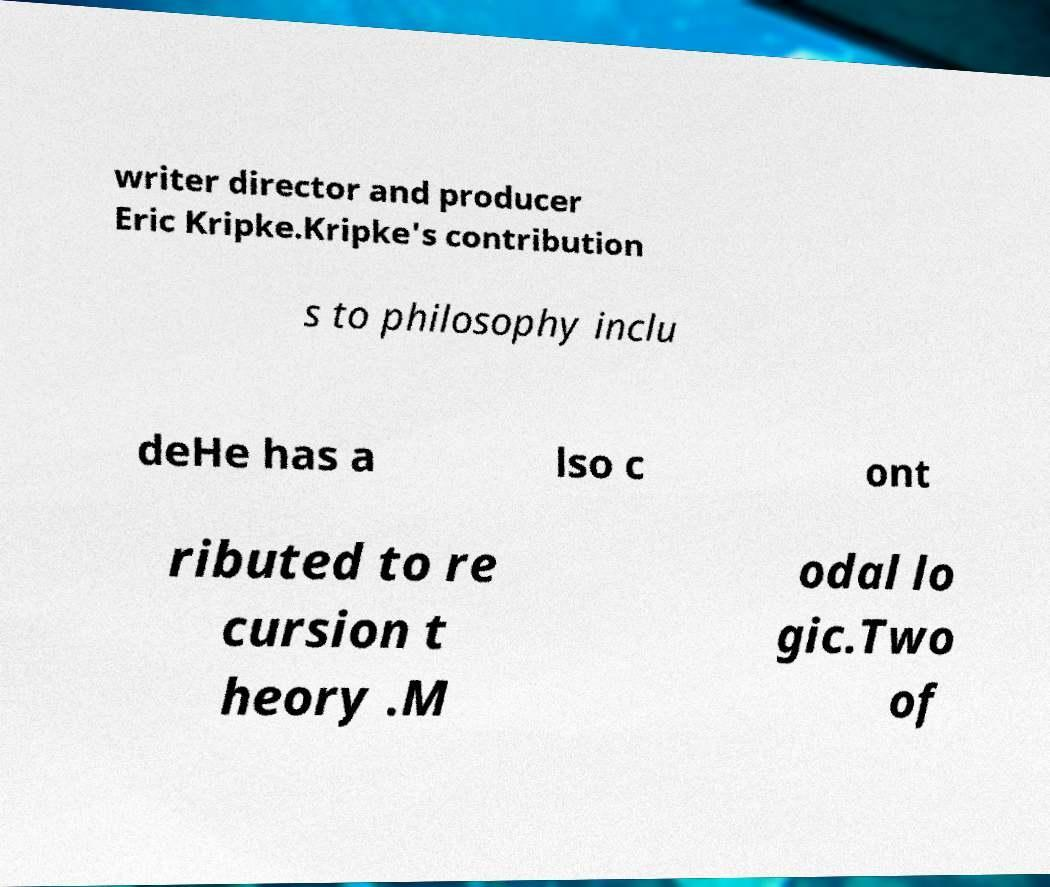I need the written content from this picture converted into text. Can you do that? writer director and producer Eric Kripke.Kripke's contribution s to philosophy inclu deHe has a lso c ont ributed to re cursion t heory .M odal lo gic.Two of 